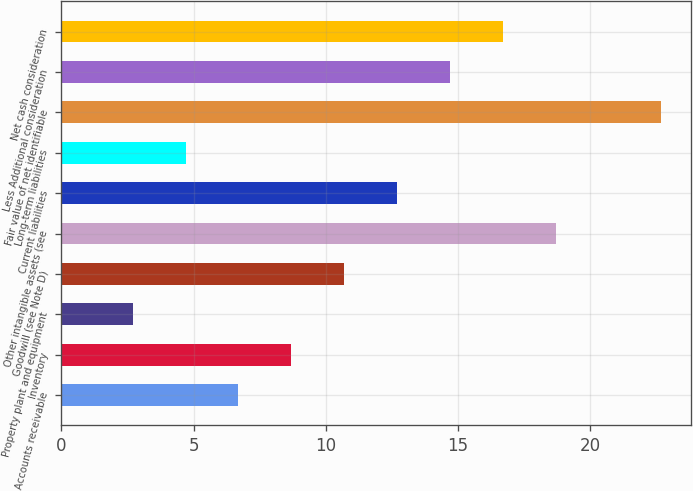<chart> <loc_0><loc_0><loc_500><loc_500><bar_chart><fcel>Accounts receivable<fcel>Inventory<fcel>Property plant and equipment<fcel>Goodwill (see Note D)<fcel>Other intangible assets (see<fcel>Current liabilities<fcel>Long-term liabilities<fcel>Fair value of net identifiable<fcel>Less Additional consideration<fcel>Net cash consideration<nl><fcel>6.7<fcel>8.7<fcel>2.7<fcel>10.7<fcel>18.7<fcel>12.7<fcel>4.7<fcel>22.7<fcel>14.7<fcel>16.7<nl></chart> 